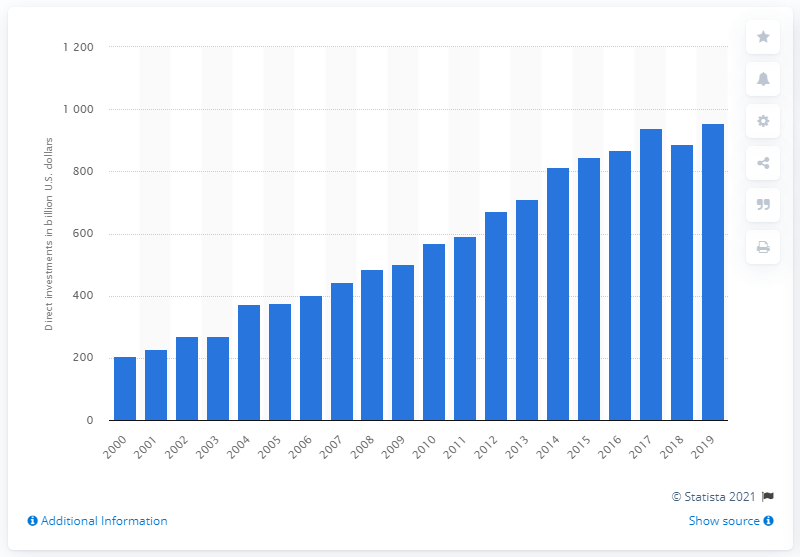Point out several critical features in this image. In 2019, the value of U.S. investments made in the Asia Pacific region was approximately $955.36 billion. 